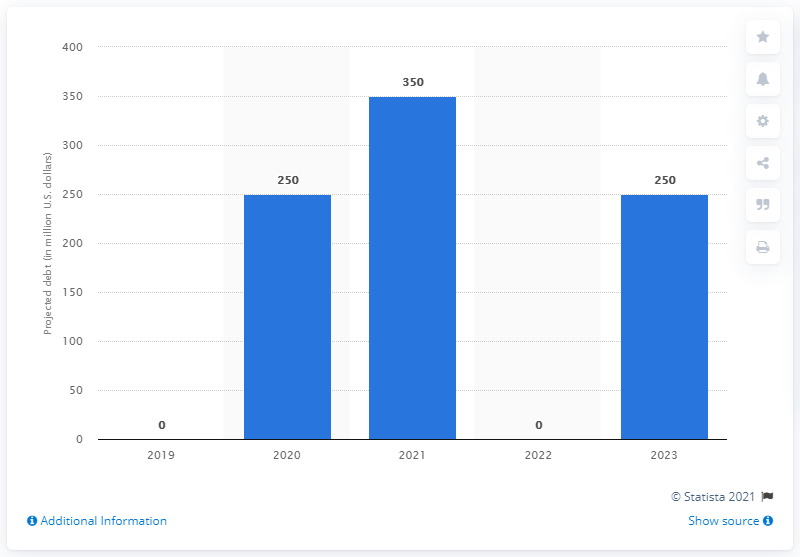List a handful of essential elements in this visual. It is projected that Mattel's debt will reach 250 million U.S. dollars in 2023. It is projected that Mattel will have debt of approximately $250 million in 2023. 